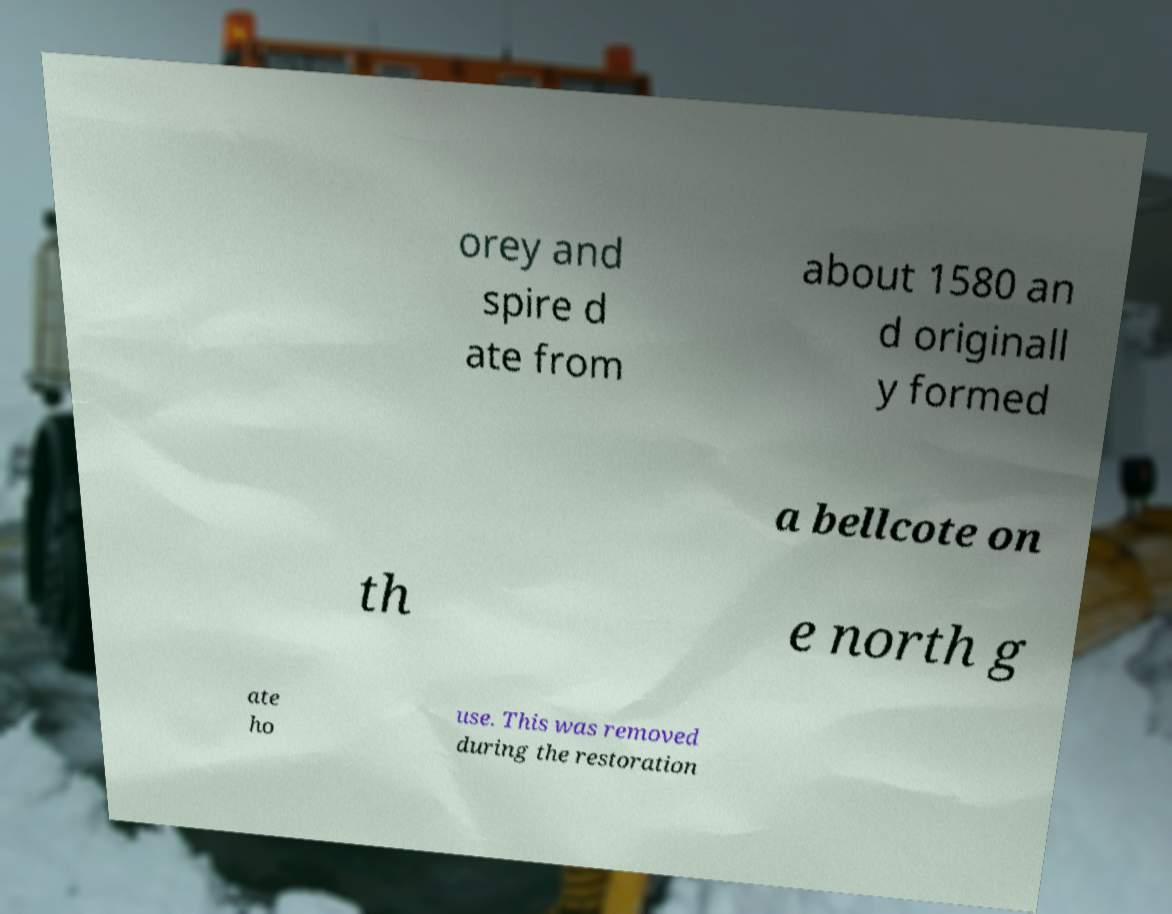Can you read and provide the text displayed in the image?This photo seems to have some interesting text. Can you extract and type it out for me? orey and spire d ate from about 1580 an d originall y formed a bellcote on th e north g ate ho use. This was removed during the restoration 